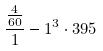<formula> <loc_0><loc_0><loc_500><loc_500>\frac { \frac { 4 } { 6 0 } } { 1 } - 1 ^ { 3 } \cdot 3 9 5</formula> 